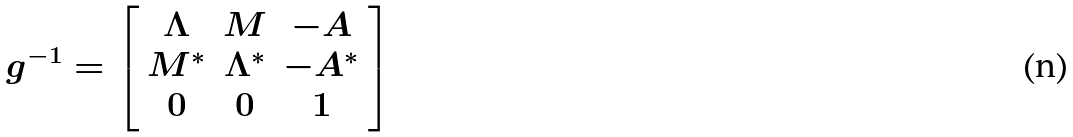Convert formula to latex. <formula><loc_0><loc_0><loc_500><loc_500>g ^ { - 1 } = \left [ \begin{array} { c c c } \Lambda & M & - A \\ M ^ { * } & \Lambda ^ { * } & - A ^ { * } \\ 0 & 0 & 1 \end{array} \right ]</formula> 